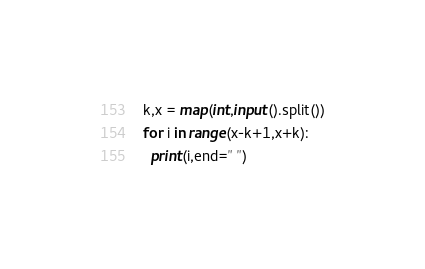Convert code to text. <code><loc_0><loc_0><loc_500><loc_500><_Python_>k,x = map(int,input().split())
for i in range(x-k+1,x+k):
  print(i,end=" ")</code> 